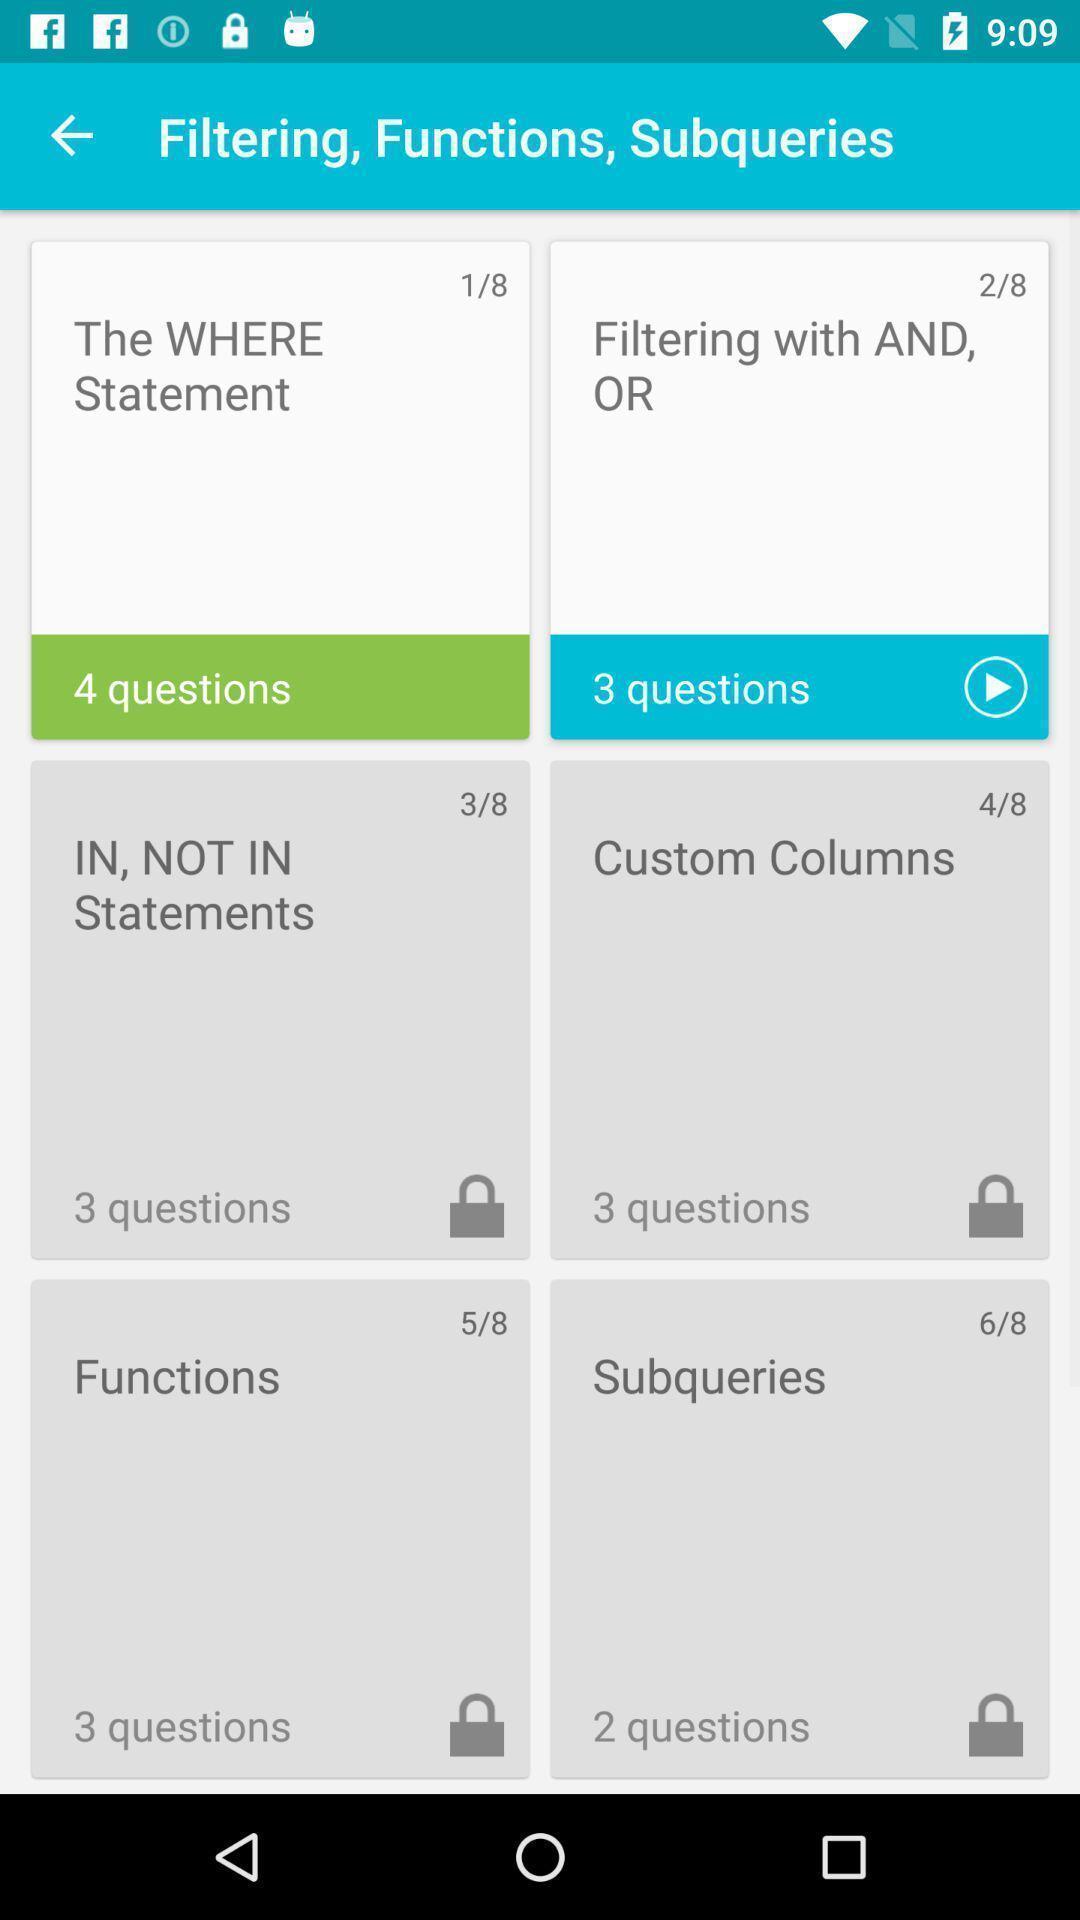Summarize the main components in this picture. Page displaying with list of different categories in learning application. 